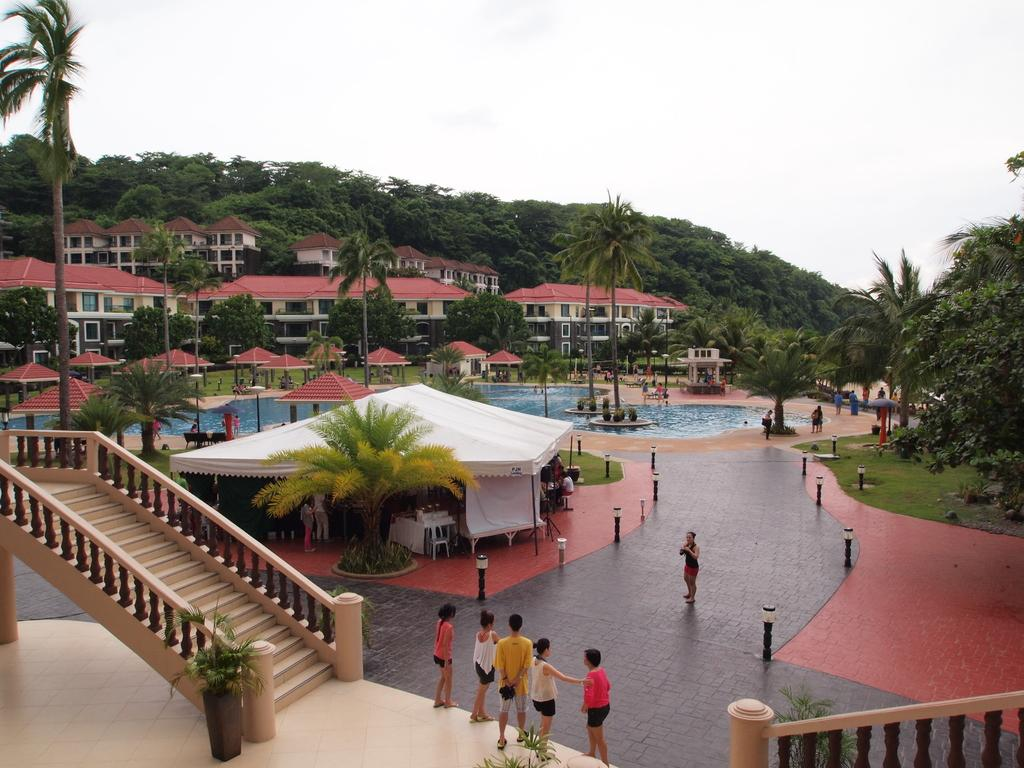What type of structure can be seen in the image? There are stairs, trees, and houses visible in the image. What natural element is present in the image? There are trees and water visible in the image. Are there any living beings in the image? Yes, there are people in the image. What is visible at the top of the image? The sky is visible at the top of the image. Can you see any bees buzzing around the trees in the image? There are no bees visible in the image; it only shows trees, houses, stairs, water, people, and the sky. Is this image taken during a holiday? There is no information provided about the time or occasion of the image, so it cannot be determined if it was taken during a holiday. 